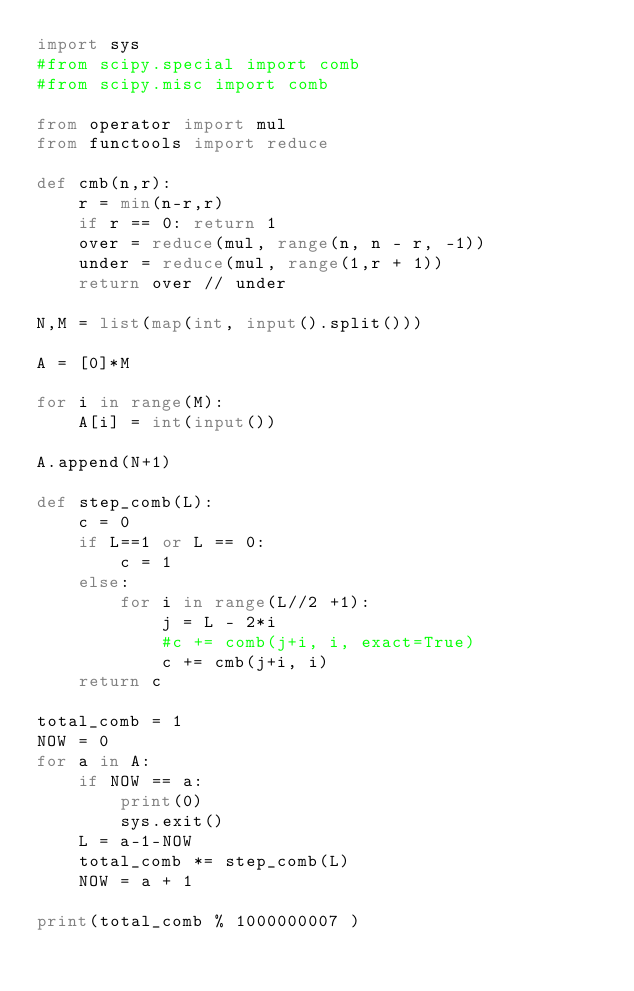<code> <loc_0><loc_0><loc_500><loc_500><_Python_>import sys
#from scipy.special import comb
#from scipy.misc import comb

from operator import mul
from functools import reduce

def cmb(n,r):
    r = min(n-r,r)
    if r == 0: return 1
    over = reduce(mul, range(n, n - r, -1))
    under = reduce(mul, range(1,r + 1))
    return over // under

N,M = list(map(int, input().split()))

A = [0]*M

for i in range(M):
    A[i] = int(input())

A.append(N+1)

def step_comb(L):
    c = 0
    if L==1 or L == 0:
        c = 1
    else:
        for i in range(L//2 +1):
            j = L - 2*i
            #c += comb(j+i, i, exact=True)
            c += cmb(j+i, i)
    return c

total_comb = 1
NOW = 0
for a in A:
    if NOW == a:
        print(0)
        sys.exit()
    L = a-1-NOW
    total_comb *= step_comb(L)
    NOW = a + 1
    
print(total_comb % 1000000007 )
</code> 